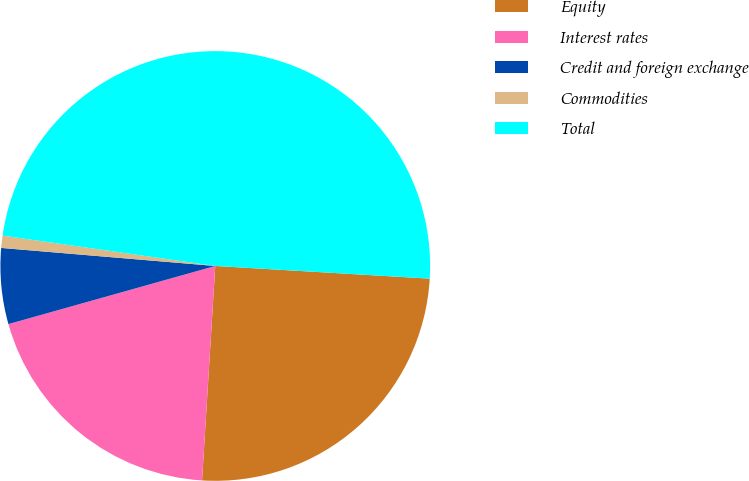Convert chart to OTSL. <chart><loc_0><loc_0><loc_500><loc_500><pie_chart><fcel>Equity<fcel>Interest rates<fcel>Credit and foreign exchange<fcel>Commodities<fcel>Total<nl><fcel>25.04%<fcel>19.66%<fcel>5.7%<fcel>0.92%<fcel>48.68%<nl></chart> 